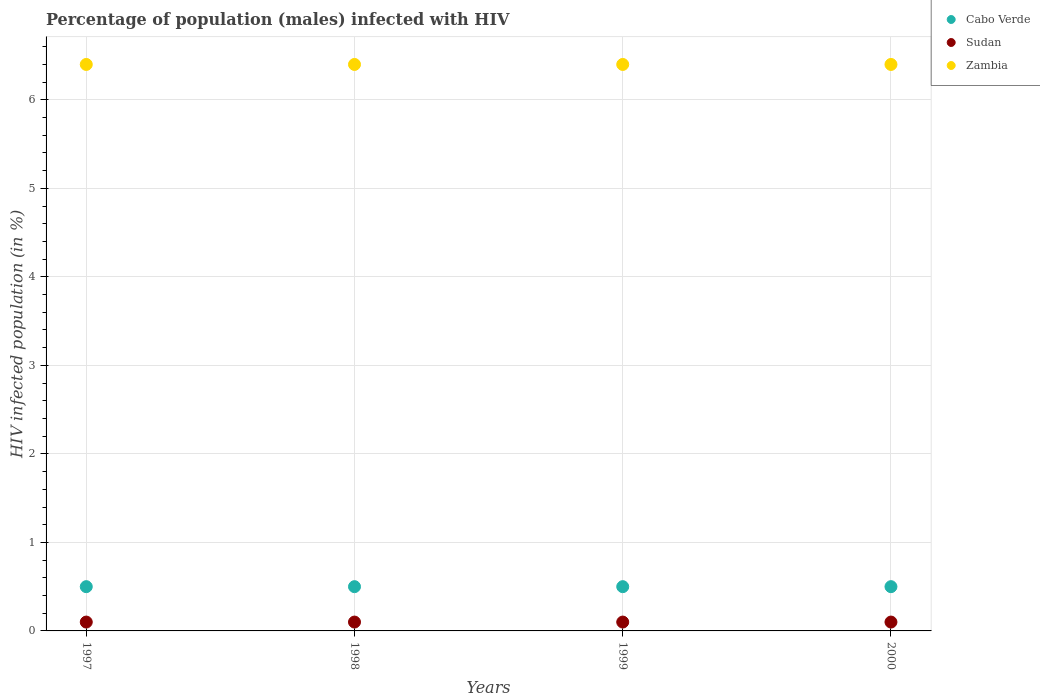How many different coloured dotlines are there?
Keep it short and to the point. 3. Is the number of dotlines equal to the number of legend labels?
Make the answer very short. Yes. In which year was the percentage of HIV infected male population in Zambia maximum?
Keep it short and to the point. 1997. In which year was the percentage of HIV infected male population in Sudan minimum?
Provide a short and direct response. 1997. What is the total percentage of HIV infected male population in Cabo Verde in the graph?
Make the answer very short. 2. What is the difference between the percentage of HIV infected male population in Zambia in 1999 and the percentage of HIV infected male population in Cabo Verde in 2000?
Your answer should be compact. 5.9. What is the average percentage of HIV infected male population in Sudan per year?
Your answer should be very brief. 0.1. Is the percentage of HIV infected male population in Sudan in 1997 less than that in 1998?
Your response must be concise. No. Is the difference between the percentage of HIV infected male population in Cabo Verde in 1998 and 2000 greater than the difference between the percentage of HIV infected male population in Sudan in 1998 and 2000?
Your answer should be compact. No. In how many years, is the percentage of HIV infected male population in Cabo Verde greater than the average percentage of HIV infected male population in Cabo Verde taken over all years?
Keep it short and to the point. 0. Does the percentage of HIV infected male population in Sudan monotonically increase over the years?
Provide a succinct answer. No. How many years are there in the graph?
Make the answer very short. 4. Does the graph contain any zero values?
Ensure brevity in your answer.  No. Where does the legend appear in the graph?
Your answer should be compact. Top right. How many legend labels are there?
Your response must be concise. 3. How are the legend labels stacked?
Ensure brevity in your answer.  Vertical. What is the title of the graph?
Your response must be concise. Percentage of population (males) infected with HIV. Does "Cuba" appear as one of the legend labels in the graph?
Make the answer very short. No. What is the label or title of the X-axis?
Provide a short and direct response. Years. What is the label or title of the Y-axis?
Make the answer very short. HIV infected population (in %). What is the HIV infected population (in %) of Cabo Verde in 1997?
Offer a terse response. 0.5. What is the HIV infected population (in %) of Sudan in 1997?
Keep it short and to the point. 0.1. What is the HIV infected population (in %) in Sudan in 1998?
Make the answer very short. 0.1. What is the HIV infected population (in %) of Zambia in 1999?
Give a very brief answer. 6.4. What is the HIV infected population (in %) of Sudan in 2000?
Offer a terse response. 0.1. What is the HIV infected population (in %) in Zambia in 2000?
Your answer should be very brief. 6.4. Across all years, what is the minimum HIV infected population (in %) of Cabo Verde?
Give a very brief answer. 0.5. What is the total HIV infected population (in %) in Cabo Verde in the graph?
Your response must be concise. 2. What is the total HIV infected population (in %) of Zambia in the graph?
Your response must be concise. 25.6. What is the difference between the HIV infected population (in %) in Sudan in 1997 and that in 1999?
Your answer should be compact. 0. What is the difference between the HIV infected population (in %) in Sudan in 1997 and that in 2000?
Keep it short and to the point. 0. What is the difference between the HIV infected population (in %) in Cabo Verde in 1998 and that in 1999?
Offer a terse response. 0. What is the difference between the HIV infected population (in %) of Sudan in 1998 and that in 1999?
Provide a succinct answer. 0. What is the difference between the HIV infected population (in %) of Zambia in 1998 and that in 1999?
Provide a short and direct response. 0. What is the difference between the HIV infected population (in %) in Zambia in 1998 and that in 2000?
Provide a short and direct response. 0. What is the difference between the HIV infected population (in %) in Sudan in 1997 and the HIV infected population (in %) in Zambia in 1998?
Your answer should be compact. -6.3. What is the difference between the HIV infected population (in %) of Cabo Verde in 1997 and the HIV infected population (in %) of Zambia in 1999?
Provide a short and direct response. -5.9. What is the difference between the HIV infected population (in %) in Sudan in 1997 and the HIV infected population (in %) in Zambia in 1999?
Make the answer very short. -6.3. What is the difference between the HIV infected population (in %) in Cabo Verde in 1997 and the HIV infected population (in %) in Zambia in 2000?
Provide a short and direct response. -5.9. What is the difference between the HIV infected population (in %) in Sudan in 1997 and the HIV infected population (in %) in Zambia in 2000?
Provide a succinct answer. -6.3. What is the difference between the HIV infected population (in %) in Cabo Verde in 1998 and the HIV infected population (in %) in Zambia in 1999?
Ensure brevity in your answer.  -5.9. What is the difference between the HIV infected population (in %) in Cabo Verde in 1998 and the HIV infected population (in %) in Sudan in 2000?
Offer a very short reply. 0.4. What is the difference between the HIV infected population (in %) of Cabo Verde in 1998 and the HIV infected population (in %) of Zambia in 2000?
Give a very brief answer. -5.9. What is the difference between the HIV infected population (in %) of Sudan in 1998 and the HIV infected population (in %) of Zambia in 2000?
Your answer should be very brief. -6.3. What is the difference between the HIV infected population (in %) of Cabo Verde in 1999 and the HIV infected population (in %) of Sudan in 2000?
Give a very brief answer. 0.4. What is the difference between the HIV infected population (in %) in Sudan in 1999 and the HIV infected population (in %) in Zambia in 2000?
Keep it short and to the point. -6.3. What is the average HIV infected population (in %) of Zambia per year?
Provide a short and direct response. 6.4. In the year 1997, what is the difference between the HIV infected population (in %) of Cabo Verde and HIV infected population (in %) of Zambia?
Your answer should be compact. -5.9. In the year 1997, what is the difference between the HIV infected population (in %) of Sudan and HIV infected population (in %) of Zambia?
Offer a terse response. -6.3. In the year 1999, what is the difference between the HIV infected population (in %) of Cabo Verde and HIV infected population (in %) of Sudan?
Your answer should be compact. 0.4. In the year 1999, what is the difference between the HIV infected population (in %) of Sudan and HIV infected population (in %) of Zambia?
Your answer should be very brief. -6.3. In the year 2000, what is the difference between the HIV infected population (in %) in Sudan and HIV infected population (in %) in Zambia?
Your response must be concise. -6.3. What is the ratio of the HIV infected population (in %) of Sudan in 1998 to that in 1999?
Offer a very short reply. 1. What is the ratio of the HIV infected population (in %) of Cabo Verde in 1999 to that in 2000?
Your response must be concise. 1. What is the ratio of the HIV infected population (in %) of Sudan in 1999 to that in 2000?
Provide a succinct answer. 1. What is the difference between the highest and the lowest HIV infected population (in %) in Zambia?
Provide a short and direct response. 0. 